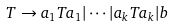Convert formula to latex. <formula><loc_0><loc_0><loc_500><loc_500>T \to a _ { 1 } T a _ { 1 } | \cdots | a _ { k } T a _ { k } | b</formula> 